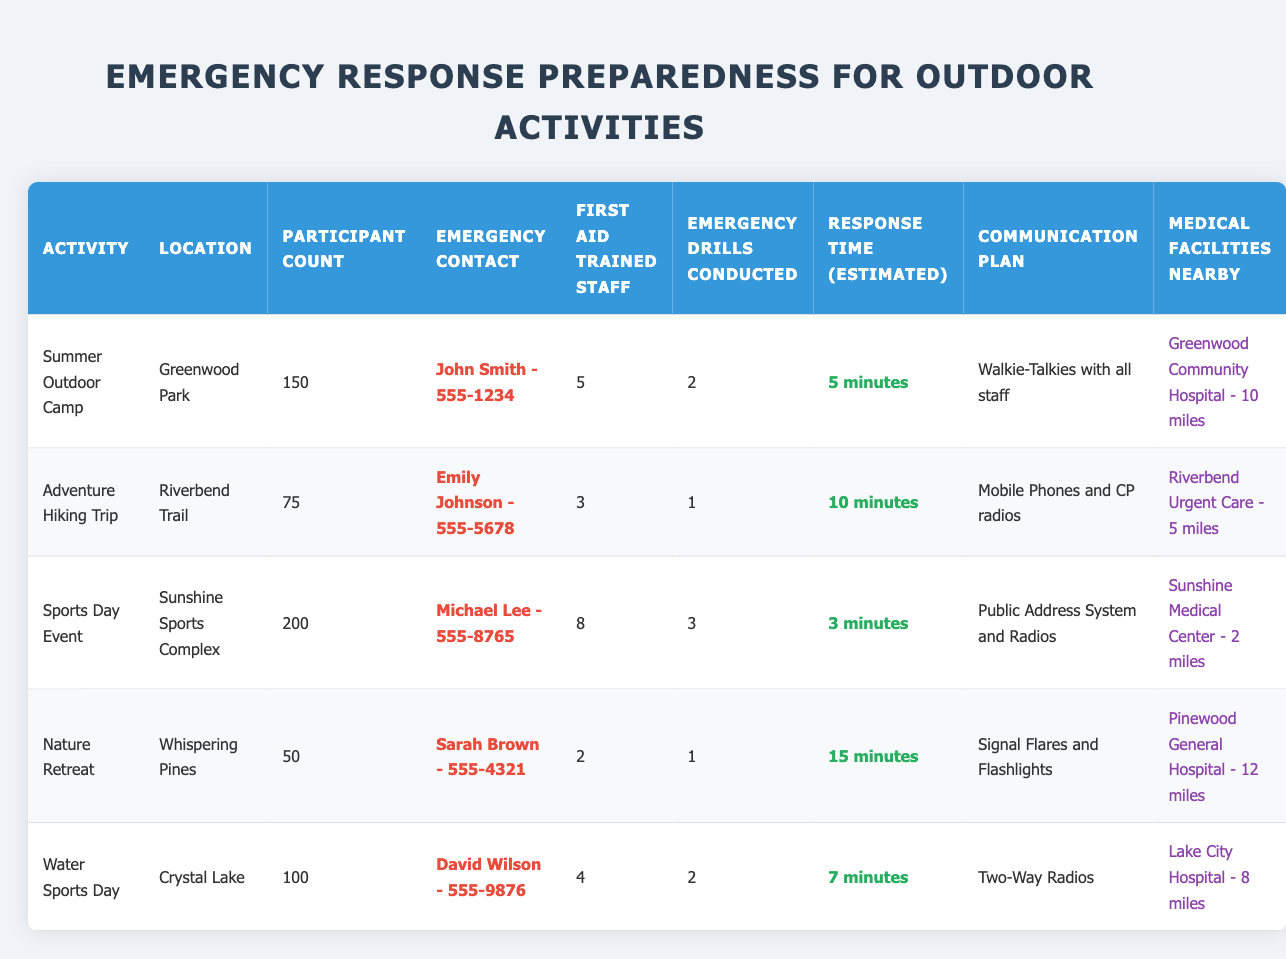What is the estimated response time for the Sports Day Event? The table shows that the estimated response time for the Sports Day Event is listed under the "Response Time (Estimated)" column. It states "3 minutes."
Answer: 3 minutes How many emergency drills were conducted for the Adventure Hiking Trip? To find this, look under the "Emergency Drills Conducted" column for the Adventure Hiking Trip. It indicates that 1 drill was conducted.
Answer: 1 Which activity has the highest number of first aid trained staff? By examining the "First Aid Trained Staff" column, the Sports Day Event indicates 8 trained staff, which is the largest number among all activities.
Answer: Sports Day Event What is the total participant count for all activities? The total participant count can be found by adding the individual counts in the "Participant Count" column: 150 + 75 + 200 + 50 + 100 = 575.
Answer: 575 Is there a medical facility located less than 5 miles from any of the activities? Check the "Medical Facilities Nearby" column for distances. The Riverbend Urgent Care is noted to be 5 miles away, so there are no facilities closer than that.
Answer: No Compare the emergency drills conducted between the Summer Outdoor Camp and the Water Sports Day. Which one conducted more drills? The Summer Outdoor Camp had 2 drills and the Water Sports Day had 2 drills as well. Therefore, both conducted the same number.
Answer: Same number (2 drills each) Which activity has the longest estimated response time and what is that time? Review the "Response Time (Estimated)" column to find the longest time. The Nature Retreat shows an estimate of 15 minutes, which is the longest duration listed.
Answer: Nature Retreat, 15 minutes What is the average number of first aid trained staff across all activities? The total number of first aid trained staff is 5 + 3 + 8 + 2 + 4 = 22. With 5 activities, divide 22 by 5, giving an average of 4.4.
Answer: 4.4 If an emergency occurs, which communication plan should you prioritize for immediate assistance? The Sports Day Event has the fastest response time of 3 minutes and a public address system, suggesting quick communication could ensure immediate assistance.
Answer: Sports Day Event, Public Address System How far is the nearest medical facility for the Water Sports Day activity? The distance listed under the "Medical Facilities Nearby" for Water Sports Day is 8 miles.
Answer: 8 miles 